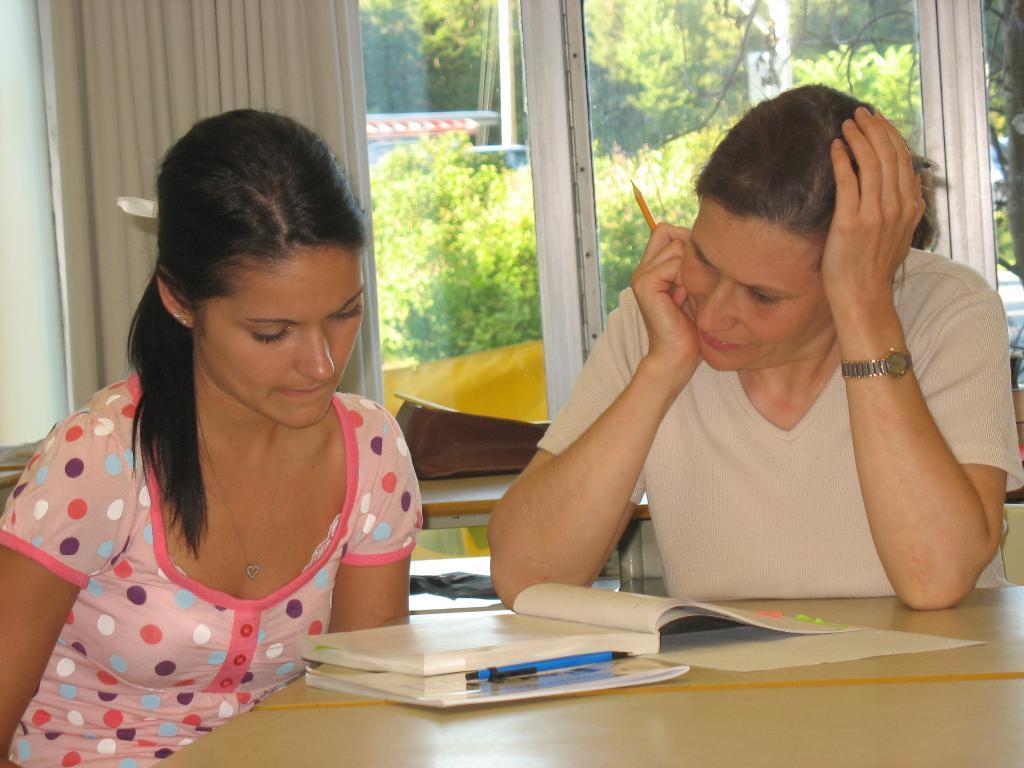Please provide a concise description of this image. In this image there are people sitting on the chairs. In front of them there is a table. On top of it there are books and a paper. Behind them there are some objects on the table. In the background of the image there is a curtain. There are glass windows through which we can see trees. 